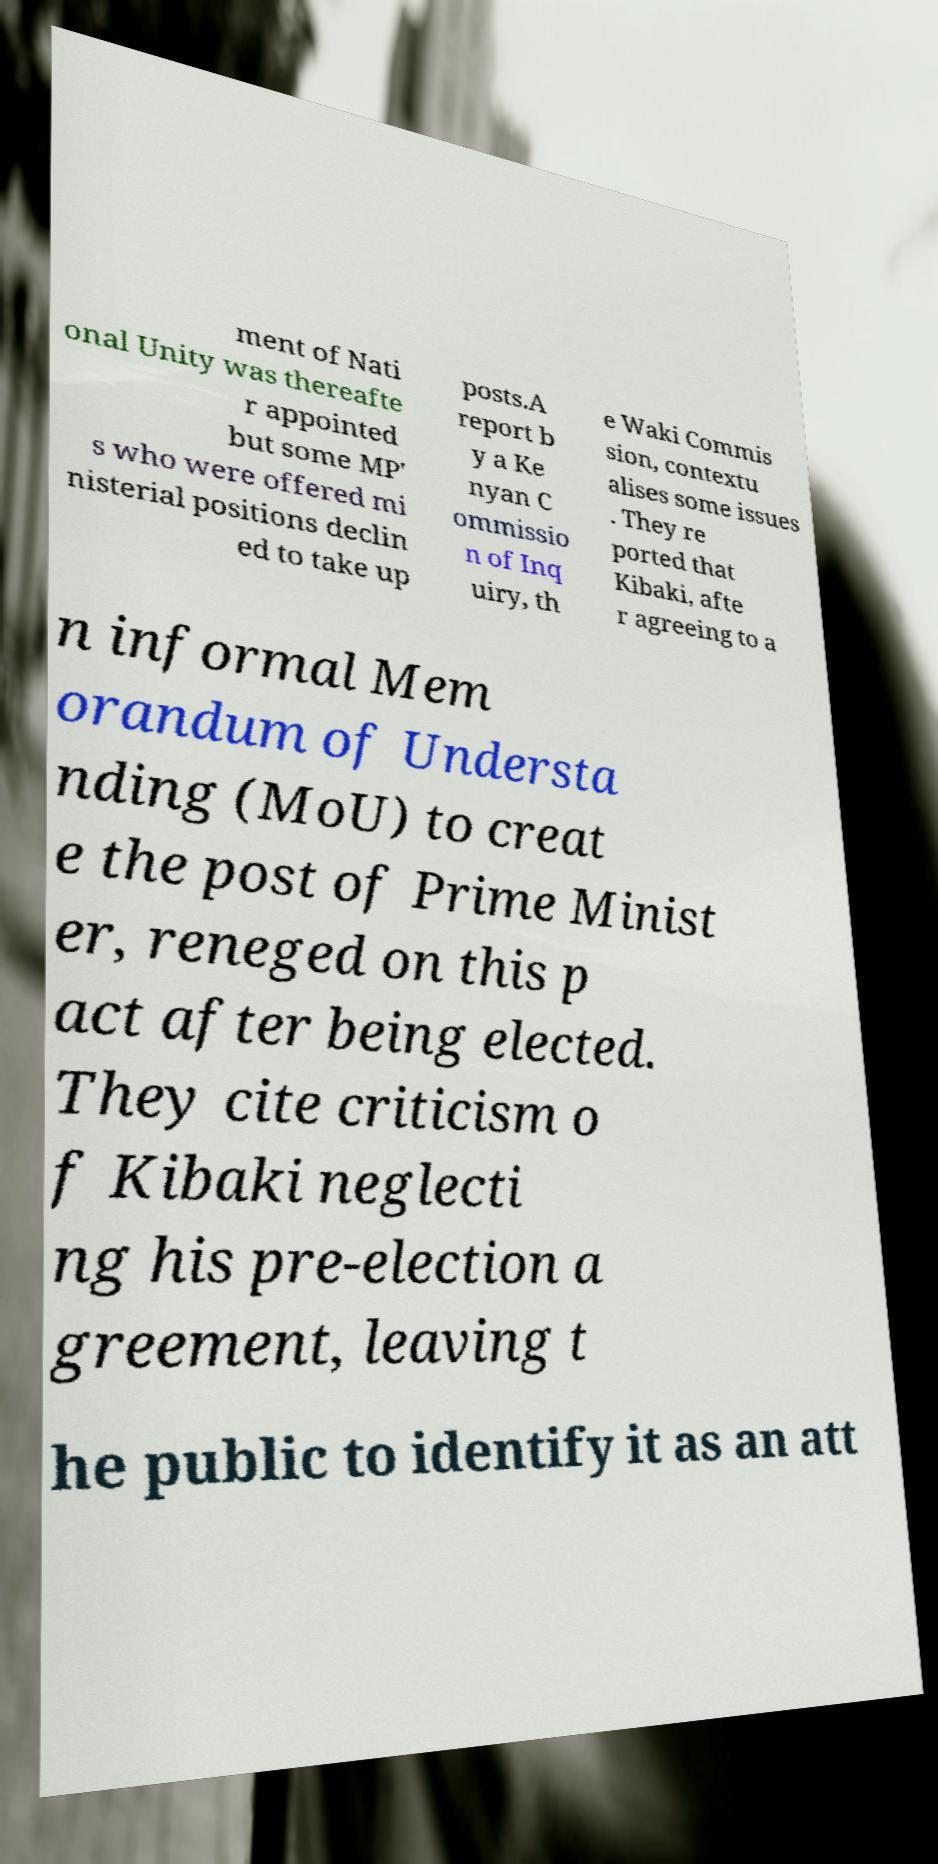I need the written content from this picture converted into text. Can you do that? ment of Nati onal Unity was thereafte r appointed but some MP' s who were offered mi nisterial positions declin ed to take up posts.A report b y a Ke nyan C ommissio n of Inq uiry, th e Waki Commis sion, contextu alises some issues . They re ported that Kibaki, afte r agreeing to a n informal Mem orandum of Understa nding (MoU) to creat e the post of Prime Minist er, reneged on this p act after being elected. They cite criticism o f Kibaki neglecti ng his pre-election a greement, leaving t he public to identify it as an att 